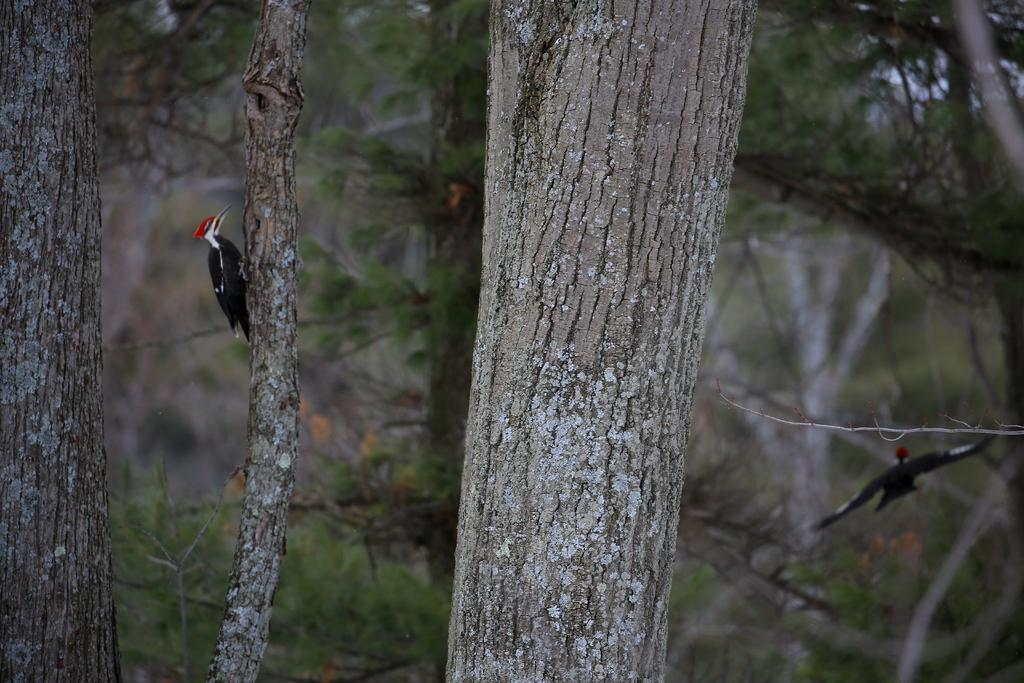What is located in the foreground of the image? There is a tree in the foreground of the image. What is on the tree in the image? There is a bird on the tree. Can you describe the bird on the right side of the image? There is another bird on the right side of the image. What can be seen in the background of the image? There are trees in the background of the image. What type of quilt is being used as an ornament on the tree in the image? There is no quilt present in the image; it features a tree with birds. What cause led to the birds gathering on the tree in the image? The image does not provide information about the cause of the birds gathering on the tree. 